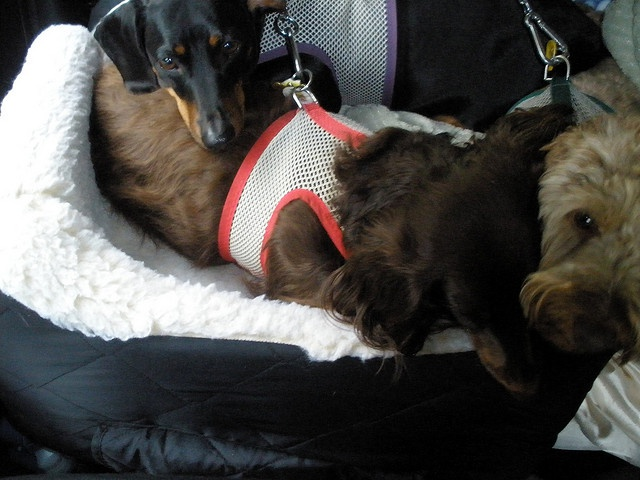Describe the objects in this image and their specific colors. I can see dog in black and gray tones, dog in black, gray, and lightgray tones, and couch in black, white, gray, and darkgray tones in this image. 